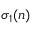<formula> <loc_0><loc_0><loc_500><loc_500>\sigma _ { 1 } ( n )</formula> 